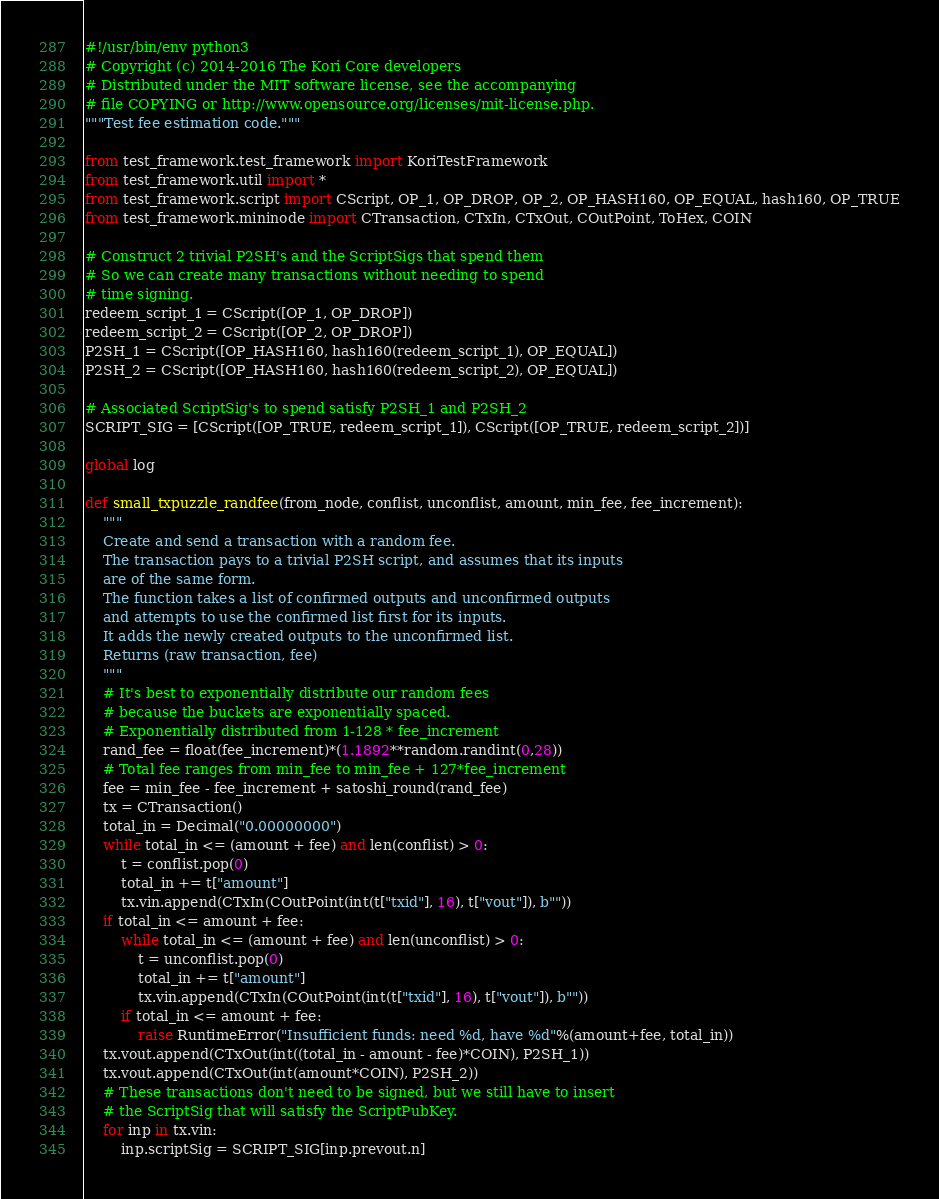Convert code to text. <code><loc_0><loc_0><loc_500><loc_500><_Python_>#!/usr/bin/env python3
# Copyright (c) 2014-2016 The Kori Core developers
# Distributed under the MIT software license, see the accompanying
# file COPYING or http://www.opensource.org/licenses/mit-license.php.
"""Test fee estimation code."""

from test_framework.test_framework import KoriTestFramework
from test_framework.util import *
from test_framework.script import CScript, OP_1, OP_DROP, OP_2, OP_HASH160, OP_EQUAL, hash160, OP_TRUE
from test_framework.mininode import CTransaction, CTxIn, CTxOut, COutPoint, ToHex, COIN

# Construct 2 trivial P2SH's and the ScriptSigs that spend them
# So we can create many transactions without needing to spend
# time signing.
redeem_script_1 = CScript([OP_1, OP_DROP])
redeem_script_2 = CScript([OP_2, OP_DROP])
P2SH_1 = CScript([OP_HASH160, hash160(redeem_script_1), OP_EQUAL])
P2SH_2 = CScript([OP_HASH160, hash160(redeem_script_2), OP_EQUAL])

# Associated ScriptSig's to spend satisfy P2SH_1 and P2SH_2
SCRIPT_SIG = [CScript([OP_TRUE, redeem_script_1]), CScript([OP_TRUE, redeem_script_2])]

global log

def small_txpuzzle_randfee(from_node, conflist, unconflist, amount, min_fee, fee_increment):
    """
    Create and send a transaction with a random fee.
    The transaction pays to a trivial P2SH script, and assumes that its inputs
    are of the same form.
    The function takes a list of confirmed outputs and unconfirmed outputs
    and attempts to use the confirmed list first for its inputs.
    It adds the newly created outputs to the unconfirmed list.
    Returns (raw transaction, fee)
    """
    # It's best to exponentially distribute our random fees
    # because the buckets are exponentially spaced.
    # Exponentially distributed from 1-128 * fee_increment
    rand_fee = float(fee_increment)*(1.1892**random.randint(0,28))
    # Total fee ranges from min_fee to min_fee + 127*fee_increment
    fee = min_fee - fee_increment + satoshi_round(rand_fee)
    tx = CTransaction()
    total_in = Decimal("0.00000000")
    while total_in <= (amount + fee) and len(conflist) > 0:
        t = conflist.pop(0)
        total_in += t["amount"]
        tx.vin.append(CTxIn(COutPoint(int(t["txid"], 16), t["vout"]), b""))
    if total_in <= amount + fee:
        while total_in <= (amount + fee) and len(unconflist) > 0:
            t = unconflist.pop(0)
            total_in += t["amount"]
            tx.vin.append(CTxIn(COutPoint(int(t["txid"], 16), t["vout"]), b""))
        if total_in <= amount + fee:
            raise RuntimeError("Insufficient funds: need %d, have %d"%(amount+fee, total_in))
    tx.vout.append(CTxOut(int((total_in - amount - fee)*COIN), P2SH_1))
    tx.vout.append(CTxOut(int(amount*COIN), P2SH_2))
    # These transactions don't need to be signed, but we still have to insert
    # the ScriptSig that will satisfy the ScriptPubKey.
    for inp in tx.vin:
        inp.scriptSig = SCRIPT_SIG[inp.prevout.n]</code> 